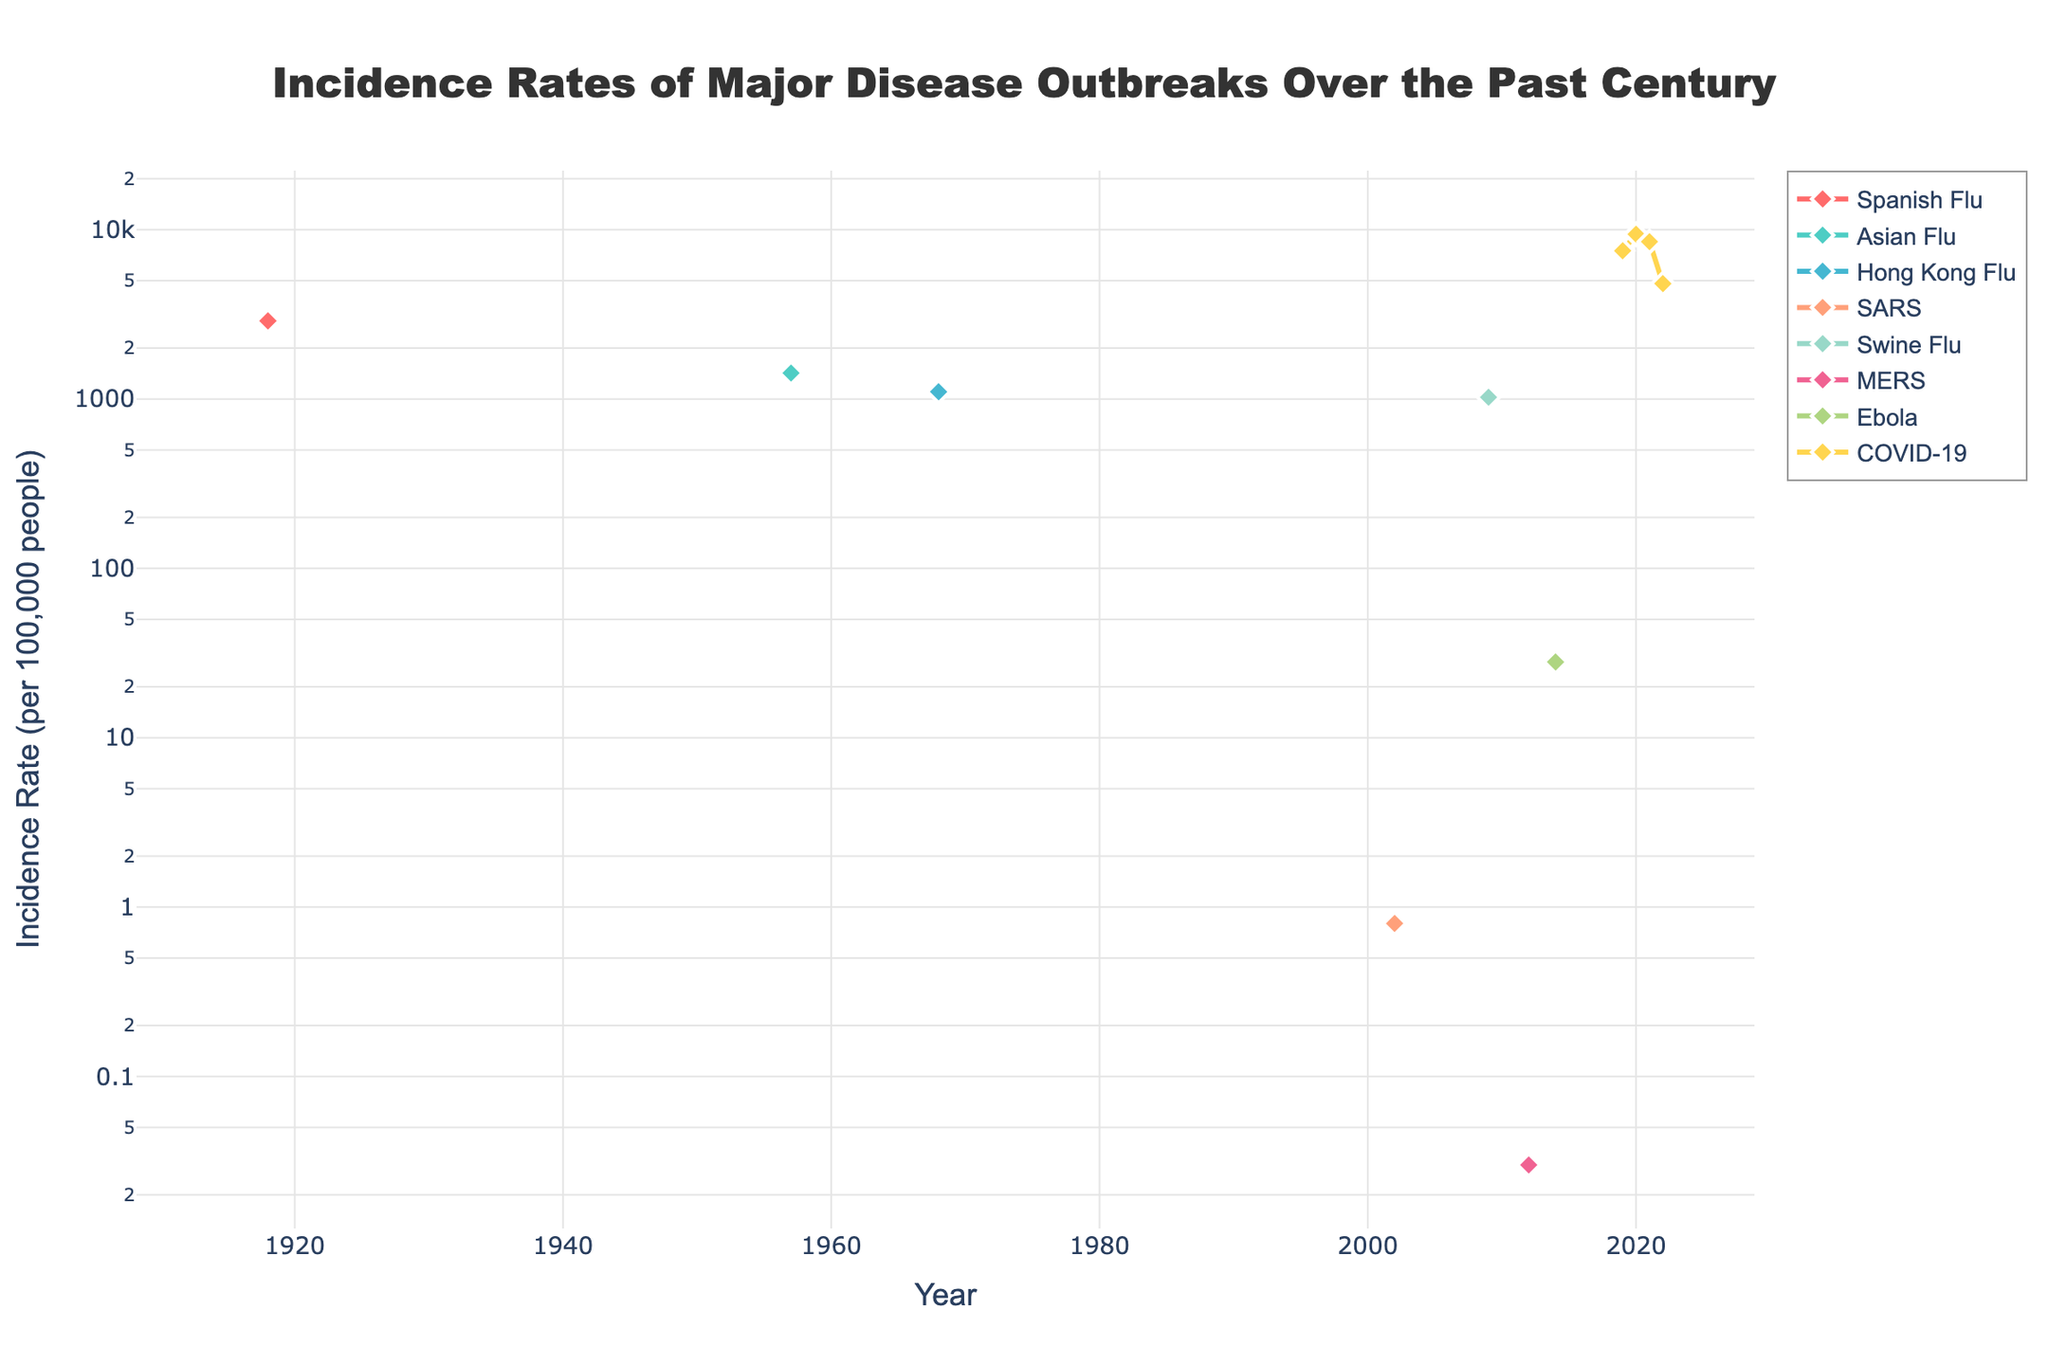What is the title of the figure? The title can be found at the top of the figure, and it is usually written in a larger font size to denote its importance.
Answer: Incidence Rates of Major Disease Outbreaks Over the Past Century What is the incidence rate of the COVID-19 outbreak in 2020? Look for the year 2020 on the x-axis and follow the COVID-19 line to see the corresponding y-axis value.
Answer: 9400 per 100,000 people How many diseases are represented in the plot? Look at the legend on the right side of the figure to count the number of unique disease names listed.
Answer: 8 What is the color of the line representing the Spanish Flu? Identify the Spanish Flu in the legend, then match it to its corresponding line color in the plot.
Answer: Red Which disease had the lowest incidence rate, and what was it? Find the point on the y-axis that corresponds to the lowest value and identify the associated disease using the legend or the data points on the figure.
Answer: MERS, 0.03 per 100,000 people Between which years did the incidence rate of COVID-19 decrease? Examine the slope of the line associated with COVID-19 and identify the points where it decreases.
Answer: From 2020 to 2022 What is the time span of the data presented in the plot? Look at the earliest and the latest years on the x-axis to determine the range covered by the plot.
Answer: 1918 to 2022 Which disease outbreak had the highest incidence rate? Check the peak values on the y-axis and match it to the corresponding disease name using the legend or the data points in the figure.
Answer: COVID-19 